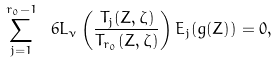Convert formula to latex. <formula><loc_0><loc_0><loc_500><loc_500>\sum _ { j = 1 } ^ { r _ { 0 } - 1 } \ 6 L _ { \nu } \left ( \frac { T _ { j } ( Z , \zeta ) } { T _ { r _ { 0 } } ( Z , \zeta ) } \right ) E _ { j } ( g ( Z ) ) = 0 ,</formula> 